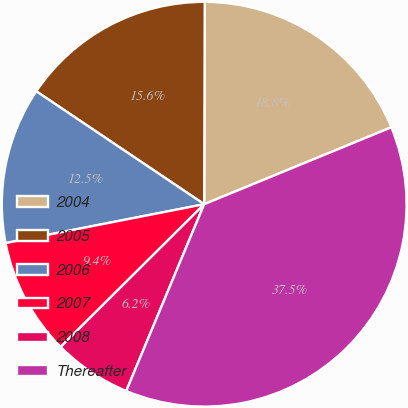<chart> <loc_0><loc_0><loc_500><loc_500><pie_chart><fcel>2004<fcel>2005<fcel>2006<fcel>2007<fcel>2008<fcel>Thereafter<nl><fcel>18.75%<fcel>15.62%<fcel>12.5%<fcel>9.38%<fcel>6.25%<fcel>37.5%<nl></chart> 